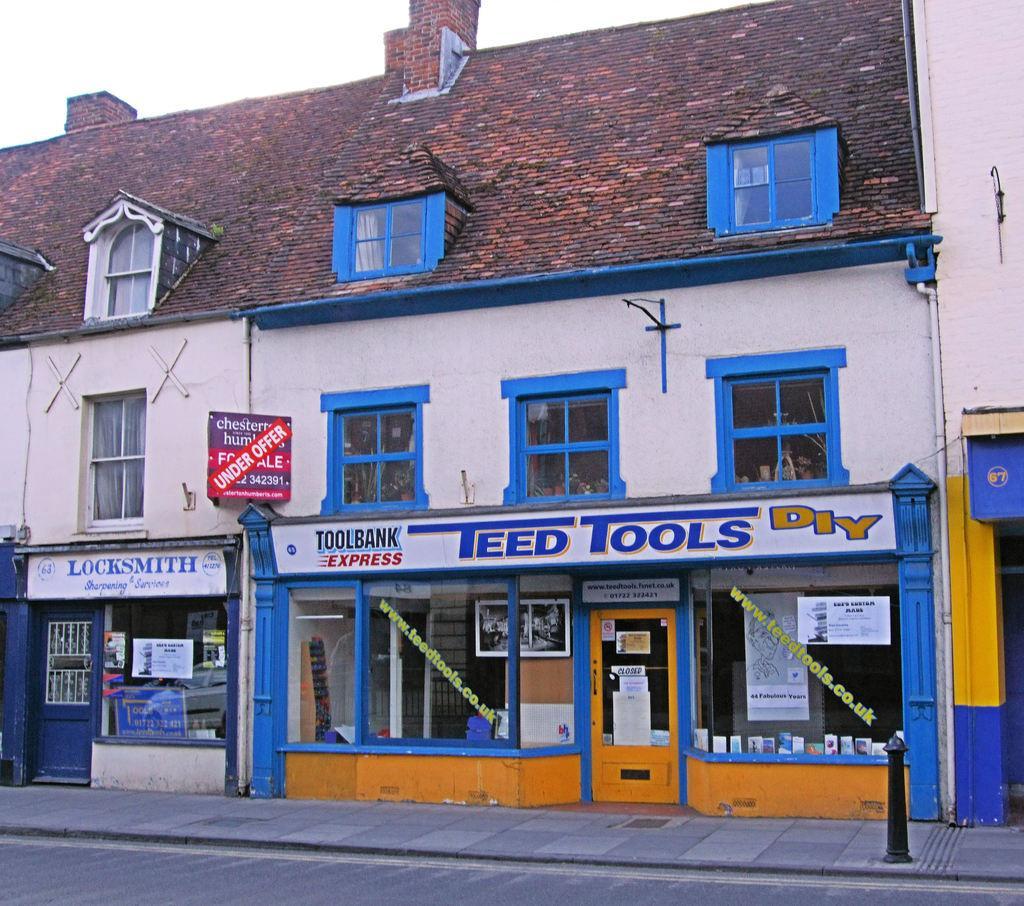Describe this image in one or two sentences. In this image in the center there is a building and on the building there are boards with some text written on it and there are windows and there are glasses. 